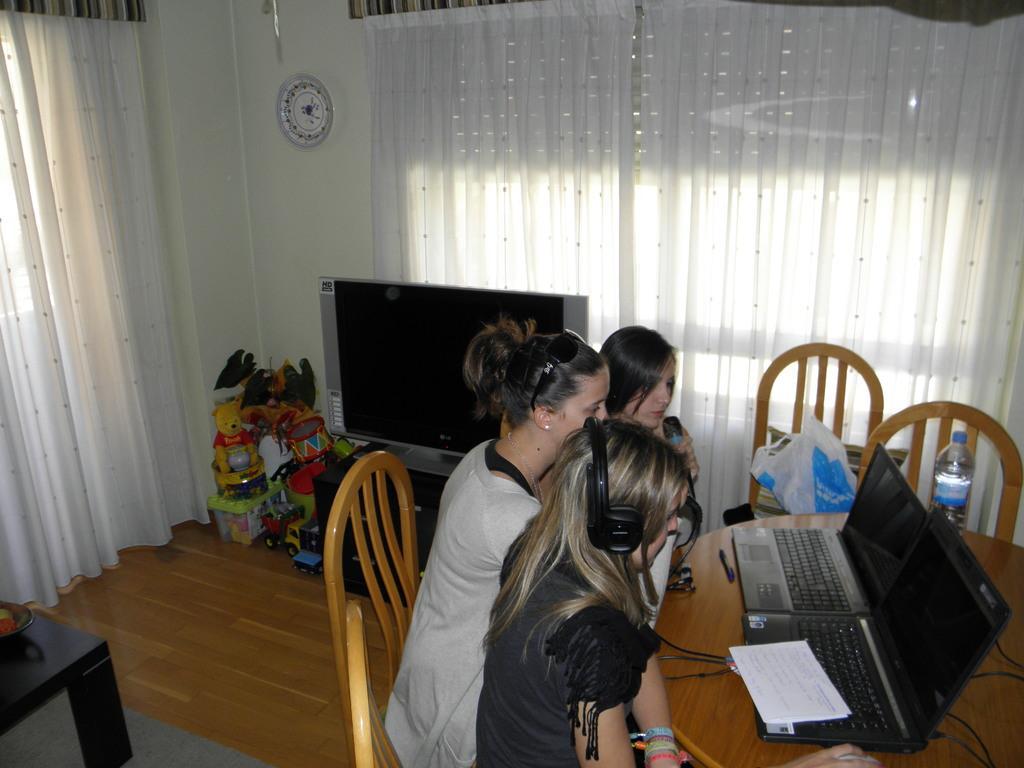How would you summarize this image in a sentence or two? In this image I can see three people siting in-front of the table. On the table there are laptops and papers. On the chair there is a bottle and some of the objects. In the back there is a television and toys behind the television. To the wall there is a clock and curtains to the window. 